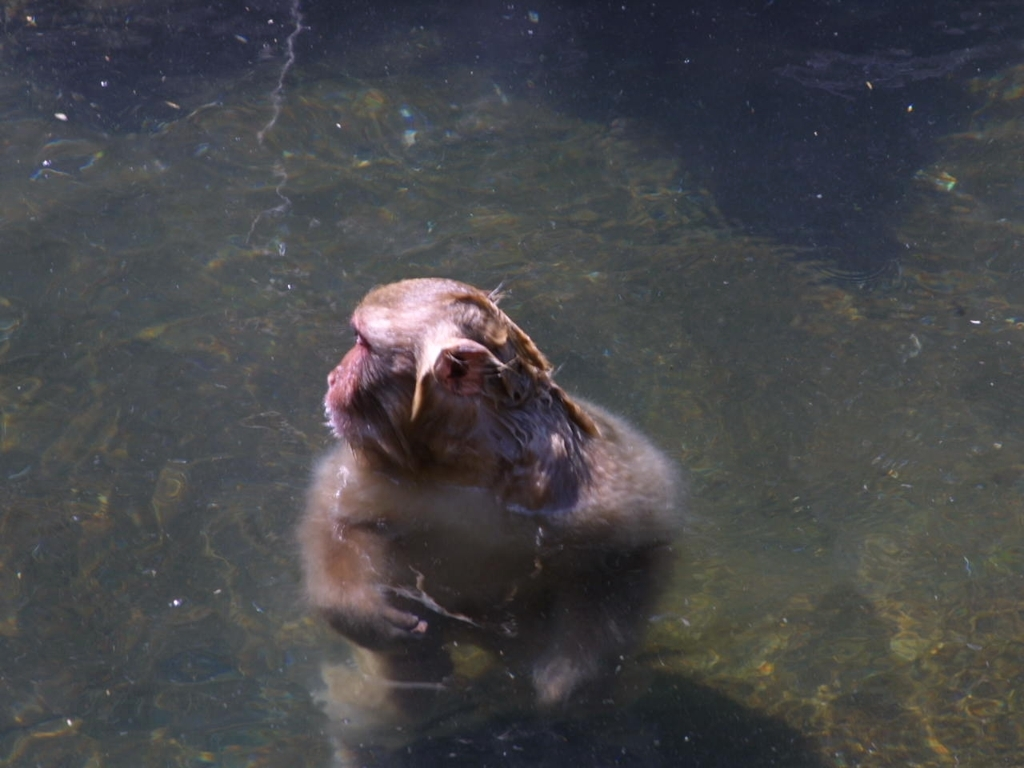What kind of animal is visible in the water? The animal in the water appears to be a monkey. Its features, such as the facial structure and fur, are characteristic of primate species commonly found in riverside habitats. 